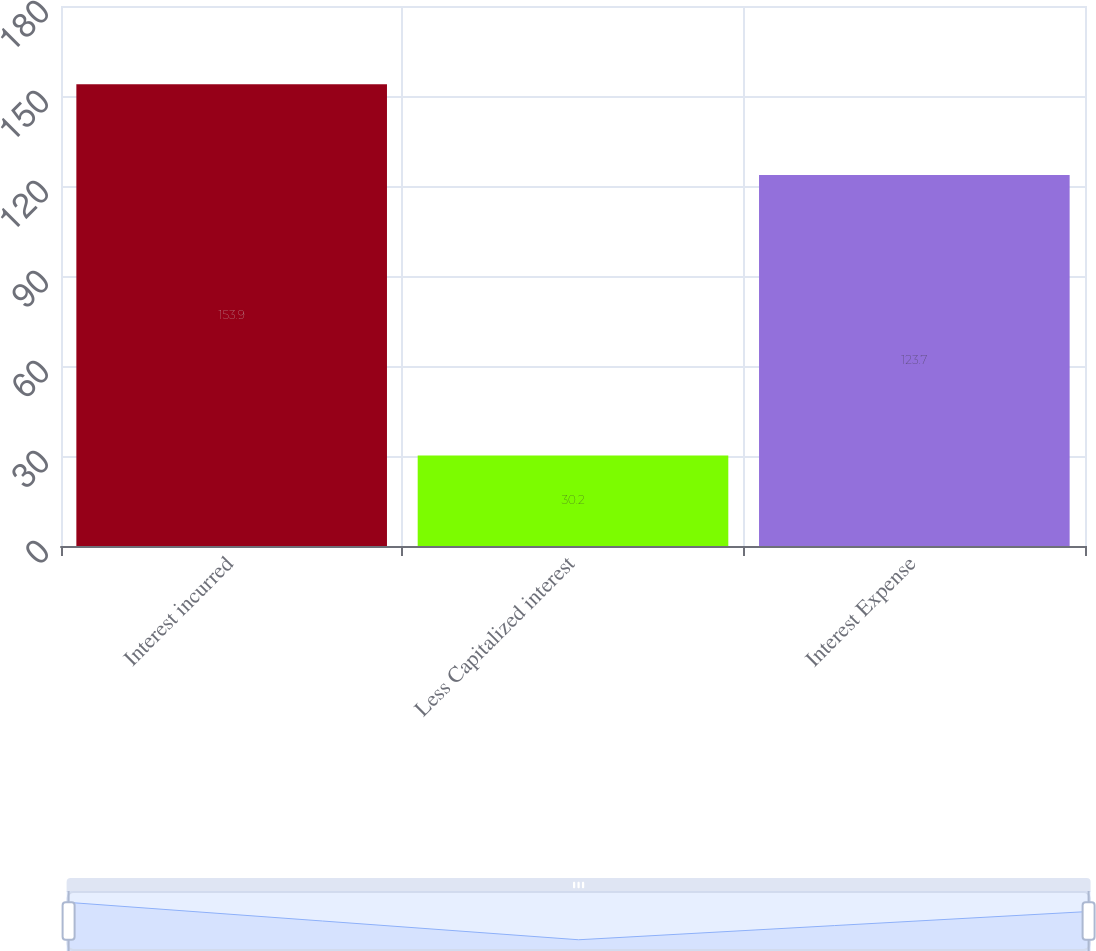Convert chart to OTSL. <chart><loc_0><loc_0><loc_500><loc_500><bar_chart><fcel>Interest incurred<fcel>Less Capitalized interest<fcel>Interest Expense<nl><fcel>153.9<fcel>30.2<fcel>123.7<nl></chart> 